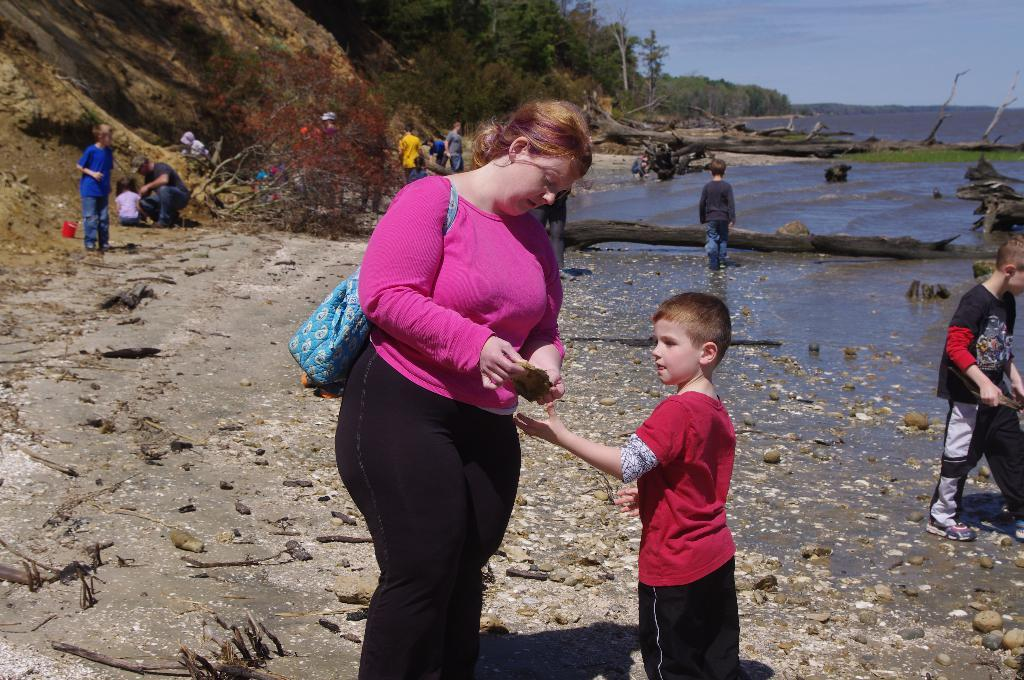Who are the people in the image? There is a woman and a boy in the image. What are the woman and boy doing? The woman and boy are standing. How many people are in the image? There is a group of people in the image. What can be seen in the background of the image? There are trees and the sky visible in the background of the image. What else can be seen in the image? There is water visible in the image. What type of slope can be seen in the image? There is no slope present in the image. How much sugar is in the water visible in the image? There is no sugar mentioned or visible in the image. 